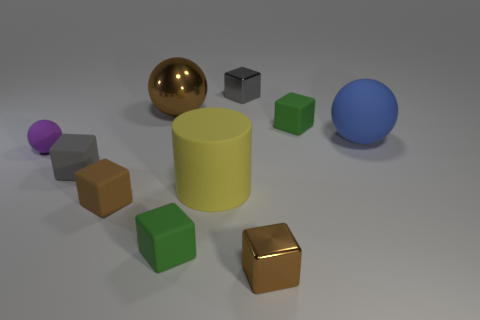Subtract all gray cubes. How many cubes are left? 4 Subtract all small gray metal cubes. How many cubes are left? 5 Subtract all red blocks. Subtract all brown spheres. How many blocks are left? 6 Subtract all balls. How many objects are left? 7 Subtract all large red metal things. Subtract all green cubes. How many objects are left? 8 Add 8 large yellow matte objects. How many large yellow matte objects are left? 9 Add 4 large cylinders. How many large cylinders exist? 5 Subtract 1 brown blocks. How many objects are left? 9 